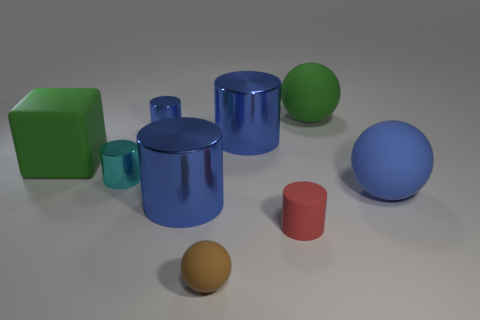There is a rubber sphere behind the cyan metal object; is its color the same as the large cube?
Offer a very short reply. Yes. There is a metallic object that is both in front of the cube and right of the cyan thing; what is its color?
Provide a short and direct response. Blue. Is there a small yellow ball that has the same material as the tiny red cylinder?
Keep it short and to the point. No. What is the size of the red cylinder?
Keep it short and to the point. Small. There is a blue thing that is right of the big metallic thing that is behind the large blue matte ball; how big is it?
Give a very brief answer. Large. What is the material of the tiny blue thing that is the same shape as the cyan object?
Provide a short and direct response. Metal. How many tiny things are there?
Offer a very short reply. 4. There is a sphere that is in front of the large matte thing that is in front of the rubber object on the left side of the tiny blue cylinder; what is its color?
Offer a terse response. Brown. Are there fewer red metal blocks than large matte things?
Offer a very short reply. Yes. What color is the other matte object that is the same shape as the cyan object?
Offer a terse response. Red. 